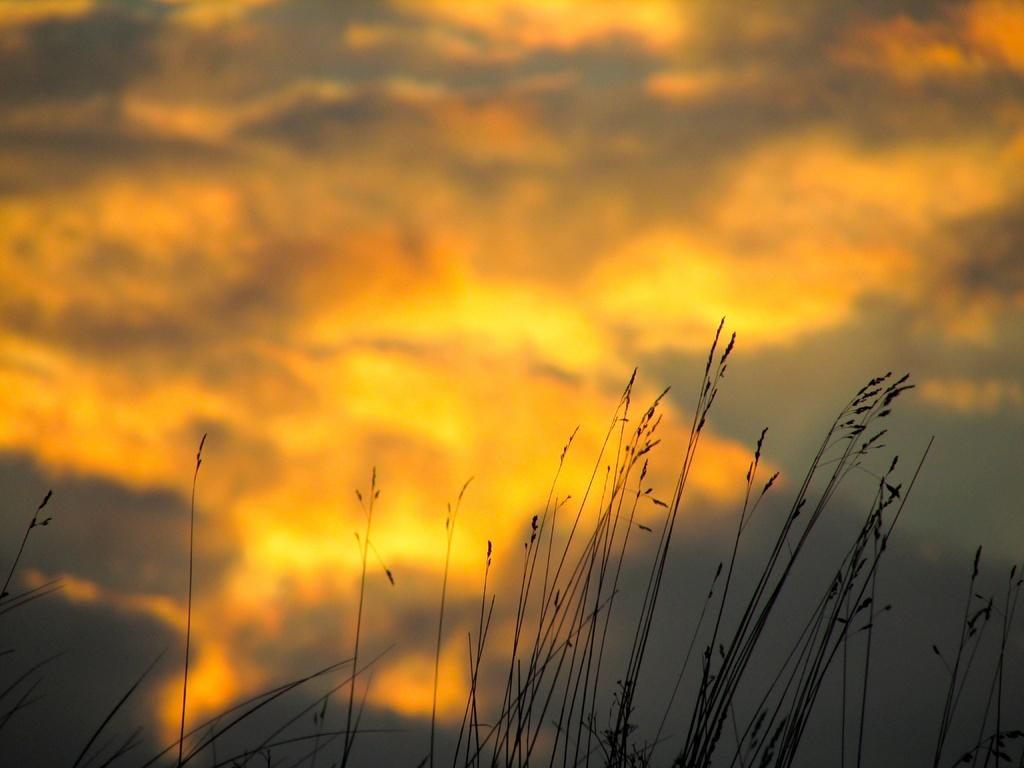What type of living organisms can be seen in the image? Plants can be seen in the image. What is visible at the top of the image? The sky is visible at the top of the image. What can be seen in the sky? There are clouds in the sky. What type of distribution is being used for the page in the image? There is no page present in the image, so it's not possible to determine the type of distribution being used. 